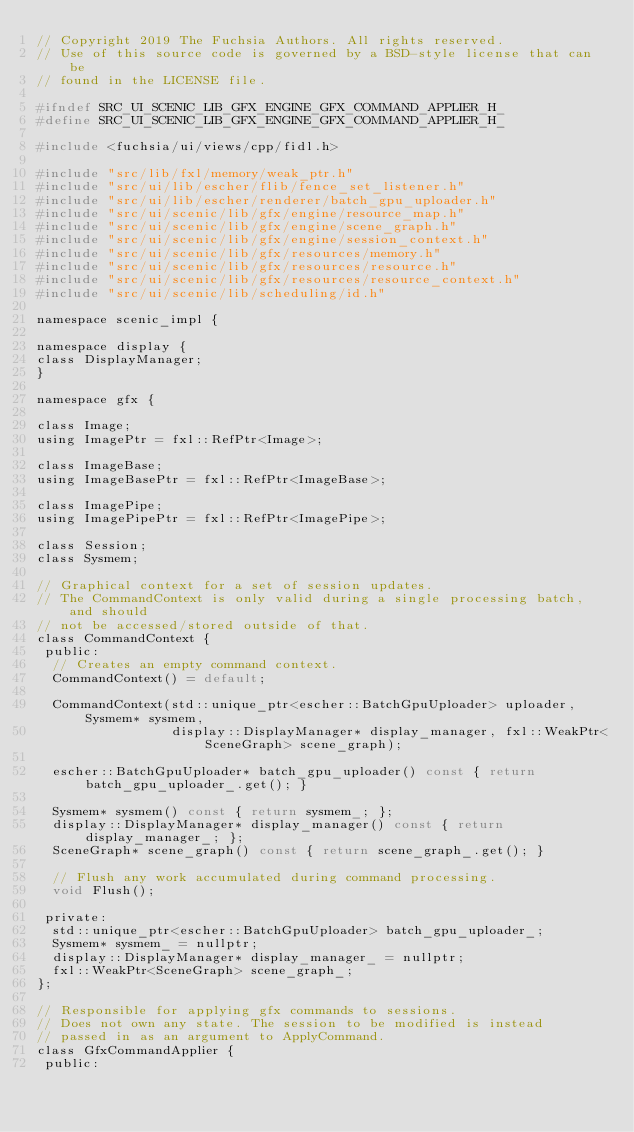Convert code to text. <code><loc_0><loc_0><loc_500><loc_500><_C_>// Copyright 2019 The Fuchsia Authors. All rights reserved.
// Use of this source code is governed by a BSD-style license that can be
// found in the LICENSE file.

#ifndef SRC_UI_SCENIC_LIB_GFX_ENGINE_GFX_COMMAND_APPLIER_H_
#define SRC_UI_SCENIC_LIB_GFX_ENGINE_GFX_COMMAND_APPLIER_H_

#include <fuchsia/ui/views/cpp/fidl.h>

#include "src/lib/fxl/memory/weak_ptr.h"
#include "src/ui/lib/escher/flib/fence_set_listener.h"
#include "src/ui/lib/escher/renderer/batch_gpu_uploader.h"
#include "src/ui/scenic/lib/gfx/engine/resource_map.h"
#include "src/ui/scenic/lib/gfx/engine/scene_graph.h"
#include "src/ui/scenic/lib/gfx/engine/session_context.h"
#include "src/ui/scenic/lib/gfx/resources/memory.h"
#include "src/ui/scenic/lib/gfx/resources/resource.h"
#include "src/ui/scenic/lib/gfx/resources/resource_context.h"
#include "src/ui/scenic/lib/scheduling/id.h"

namespace scenic_impl {

namespace display {
class DisplayManager;
}

namespace gfx {

class Image;
using ImagePtr = fxl::RefPtr<Image>;

class ImageBase;
using ImageBasePtr = fxl::RefPtr<ImageBase>;

class ImagePipe;
using ImagePipePtr = fxl::RefPtr<ImagePipe>;

class Session;
class Sysmem;

// Graphical context for a set of session updates.
// The CommandContext is only valid during a single processing batch, and should
// not be accessed/stored outside of that.
class CommandContext {
 public:
  // Creates an empty command context.
  CommandContext() = default;

  CommandContext(std::unique_ptr<escher::BatchGpuUploader> uploader, Sysmem* sysmem,
                 display::DisplayManager* display_manager, fxl::WeakPtr<SceneGraph> scene_graph);

  escher::BatchGpuUploader* batch_gpu_uploader() const { return batch_gpu_uploader_.get(); }

  Sysmem* sysmem() const { return sysmem_; };
  display::DisplayManager* display_manager() const { return display_manager_; };
  SceneGraph* scene_graph() const { return scene_graph_.get(); }

  // Flush any work accumulated during command processing.
  void Flush();

 private:
  std::unique_ptr<escher::BatchGpuUploader> batch_gpu_uploader_;
  Sysmem* sysmem_ = nullptr;
  display::DisplayManager* display_manager_ = nullptr;
  fxl::WeakPtr<SceneGraph> scene_graph_;
};

// Responsible for applying gfx commands to sessions.
// Does not own any state. The session to be modified is instead
// passed in as an argument to ApplyCommand.
class GfxCommandApplier {
 public:</code> 